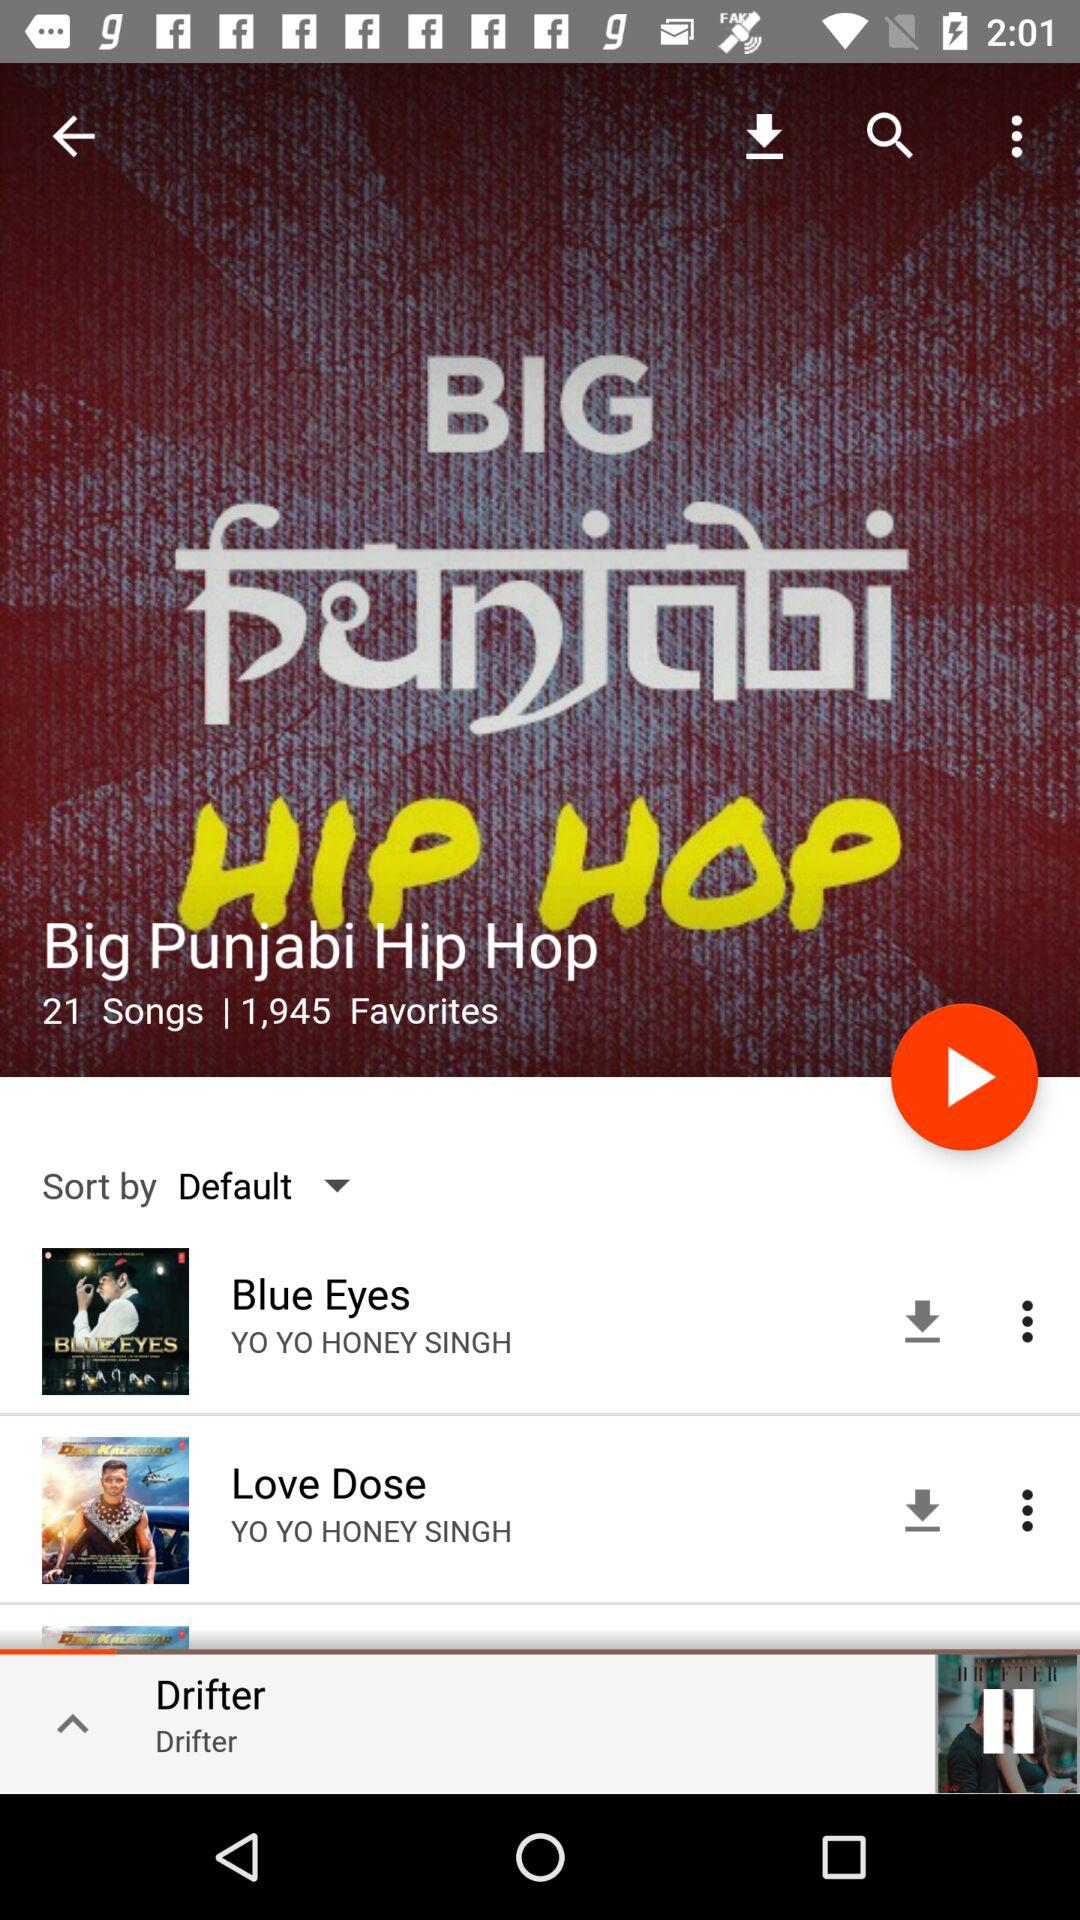What is the count of favorites? The count is 1,945. 